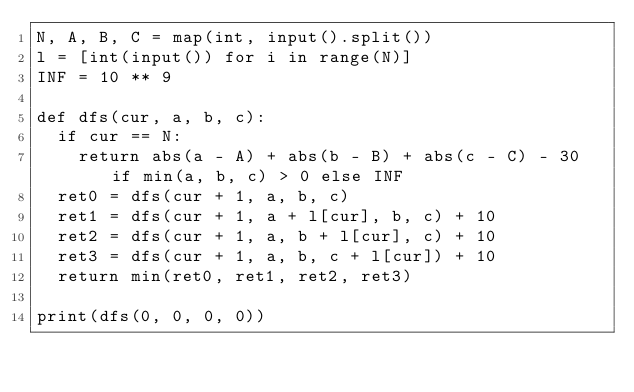<code> <loc_0><loc_0><loc_500><loc_500><_Python_>N, A, B, C = map(int, input().split())
l = [int(input()) for i in range(N)]
INF = 10 ** 9

def dfs(cur, a, b, c):
	if cur == N:
		return abs(a - A) + abs(b - B) + abs(c - C) - 30 if min(a, b, c) > 0 else INF
	ret0 = dfs(cur + 1, a, b, c)
	ret1 = dfs(cur + 1, a + l[cur], b, c) + 10
	ret2 = dfs(cur + 1, a, b + l[cur], c) + 10
	ret3 = dfs(cur + 1, a, b, c + l[cur]) + 10
	return min(ret0, ret1, ret2, ret3)

print(dfs(0, 0, 0, 0))</code> 